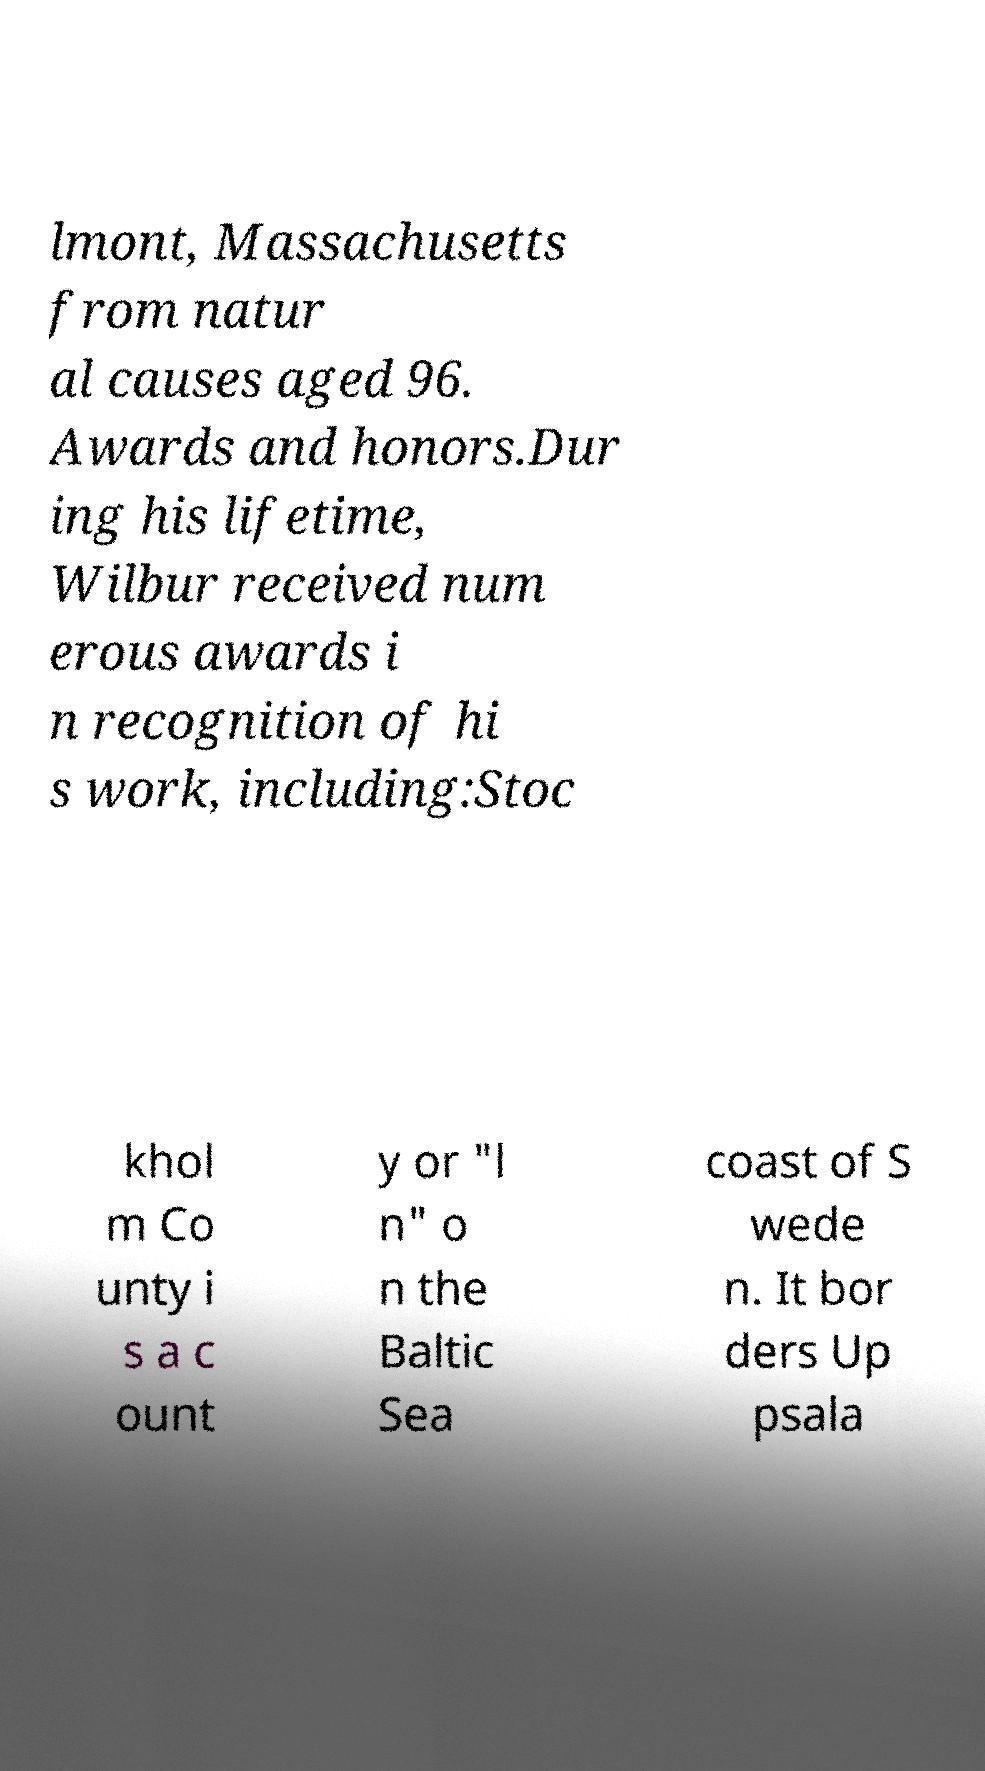Please identify and transcribe the text found in this image. lmont, Massachusetts from natur al causes aged 96. Awards and honors.Dur ing his lifetime, Wilbur received num erous awards i n recognition of hi s work, including:Stoc khol m Co unty i s a c ount y or "l n" o n the Baltic Sea coast of S wede n. It bor ders Up psala 